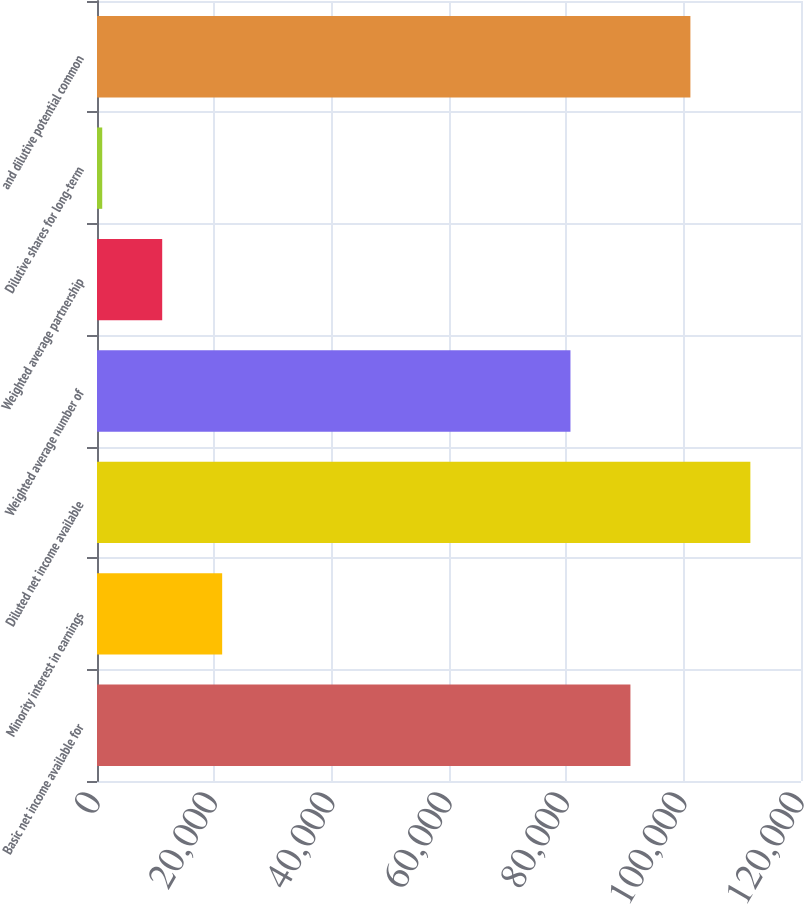Convert chart. <chart><loc_0><loc_0><loc_500><loc_500><bar_chart><fcel>Basic net income available for<fcel>Minority interest in earnings<fcel>Diluted net income available<fcel>Weighted average number of<fcel>Weighted average partnership<fcel>Dilutive shares for long-term<fcel>and dilutive potential common<nl><fcel>90926<fcel>21336<fcel>111370<fcel>80704<fcel>11114<fcel>892<fcel>101148<nl></chart> 